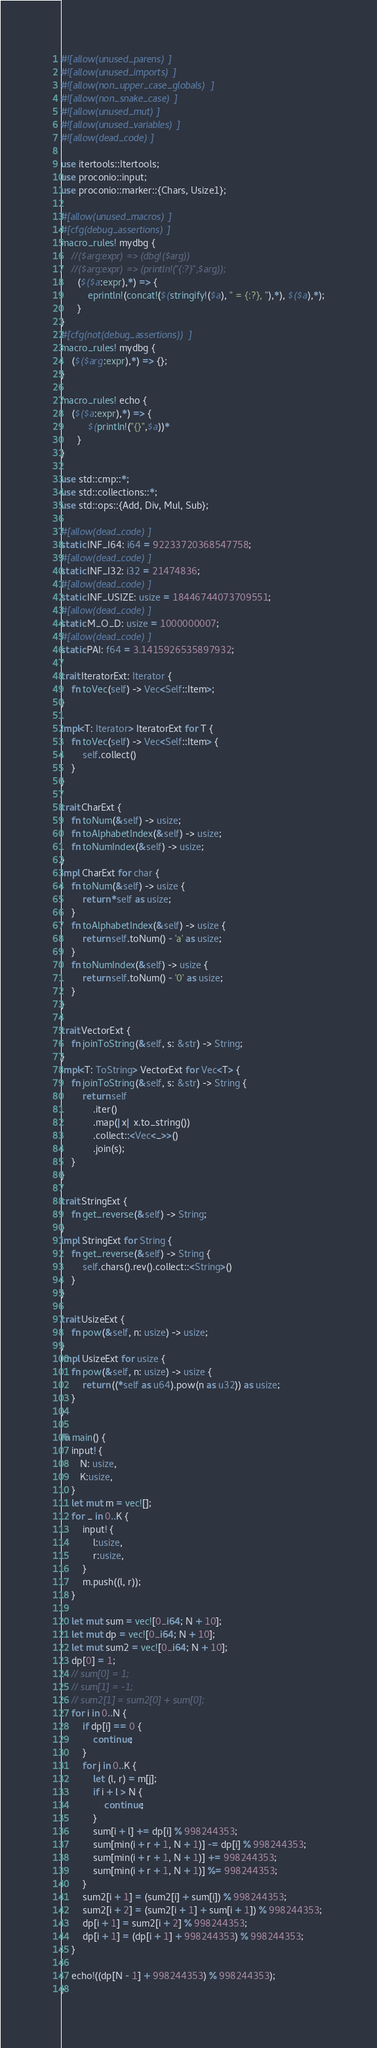<code> <loc_0><loc_0><loc_500><loc_500><_Rust_>#![allow(unused_parens)]
#![allow(unused_imports)]
#![allow(non_upper_case_globals)]
#![allow(non_snake_case)]
#![allow(unused_mut)]
#![allow(unused_variables)]
#![allow(dead_code)]

use itertools::Itertools;
use proconio::input;
use proconio::marker::{Chars, Usize1};

#[allow(unused_macros)]
#[cfg(debug_assertions)]
macro_rules! mydbg {
    //($arg:expr) => (dbg!($arg))
    //($arg:expr) => (println!("{:?}",$arg));
      ($($a:expr),*) => {
          eprintln!(concat!($(stringify!($a), " = {:?}, "),*), $($a),*);
      }
}
#[cfg(not(debug_assertions))]
macro_rules! mydbg {
    ($($arg:expr),*) => {};
}

macro_rules! echo {
    ($($a:expr),*) => {
          $(println!("{}",$a))*
      }
}

use std::cmp::*;
use std::collections::*;
use std::ops::{Add, Div, Mul, Sub};

#[allow(dead_code)]
static INF_I64: i64 = 92233720368547758;
#[allow(dead_code)]
static INF_I32: i32 = 21474836;
#[allow(dead_code)]
static INF_USIZE: usize = 18446744073709551;
#[allow(dead_code)]
static M_O_D: usize = 1000000007;
#[allow(dead_code)]
static PAI: f64 = 3.1415926535897932;

trait IteratorExt: Iterator {
    fn toVec(self) -> Vec<Self::Item>;
}

impl<T: Iterator> IteratorExt for T {
    fn toVec(self) -> Vec<Self::Item> {
        self.collect()
    }
}

trait CharExt {
    fn toNum(&self) -> usize;
    fn toAlphabetIndex(&self) -> usize;
    fn toNumIndex(&self) -> usize;
}
impl CharExt for char {
    fn toNum(&self) -> usize {
        return *self as usize;
    }
    fn toAlphabetIndex(&self) -> usize {
        return self.toNum() - 'a' as usize;
    }
    fn toNumIndex(&self) -> usize {
        return self.toNum() - '0' as usize;
    }
}

trait VectorExt {
    fn joinToString(&self, s: &str) -> String;
}
impl<T: ToString> VectorExt for Vec<T> {
    fn joinToString(&self, s: &str) -> String {
        return self
            .iter()
            .map(|x| x.to_string())
            .collect::<Vec<_>>()
            .join(s);
    }
}

trait StringExt {
    fn get_reverse(&self) -> String;
}
impl StringExt for String {
    fn get_reverse(&self) -> String {
        self.chars().rev().collect::<String>()
    }
}

trait UsizeExt {
    fn pow(&self, n: usize) -> usize;
}
impl UsizeExt for usize {
    fn pow(&self, n: usize) -> usize {
        return ((*self as u64).pow(n as u32)) as usize;
    }
}

fn main() {
    input! {
       N: usize,
       K:usize,
    }
    let mut m = vec![];
    for _ in 0..K {
        input! {
            l:usize,
            r:usize,
        }
        m.push((l, r));
    }

    let mut sum = vec![0_i64; N + 10];
    let mut dp = vec![0_i64; N + 10];
    let mut sum2 = vec![0_i64; N + 10];
    dp[0] = 1;
    // sum[0] = 1;
    // sum[1] = -1;
    // sum2[1] = sum2[0] + sum[0];
    for i in 0..N {
        if dp[i] == 0 {
            continue;
        }
        for j in 0..K {
            let (l, r) = m[j];
            if i + l > N {
                continue;
            }
            sum[i + l] += dp[i] % 998244353;
            sum[min(i + r + 1, N + 1)] -= dp[i] % 998244353;
            sum[min(i + r + 1, N + 1)] += 998244353;
            sum[min(i + r + 1, N + 1)] %= 998244353;
        }
        sum2[i + 1] = (sum2[i] + sum[i]) % 998244353;
        sum2[i + 2] = (sum2[i + 1] + sum[i + 1]) % 998244353;
        dp[i + 1] = sum2[i + 2] % 998244353;
        dp[i + 1] = (dp[i + 1] + 998244353) % 998244353;
    }

    echo!((dp[N - 1] + 998244353) % 998244353);
}
</code> 